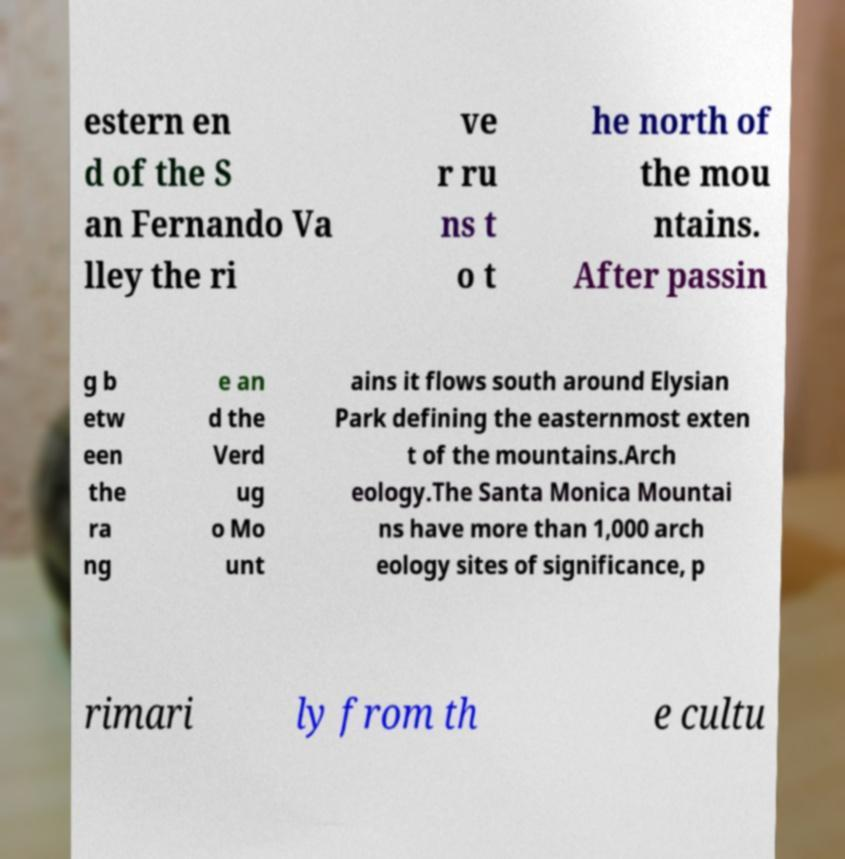Could you extract and type out the text from this image? estern en d of the S an Fernando Va lley the ri ve r ru ns t o t he north of the mou ntains. After passin g b etw een the ra ng e an d the Verd ug o Mo unt ains it flows south around Elysian Park defining the easternmost exten t of the mountains.Arch eology.The Santa Monica Mountai ns have more than 1,000 arch eology sites of significance, p rimari ly from th e cultu 